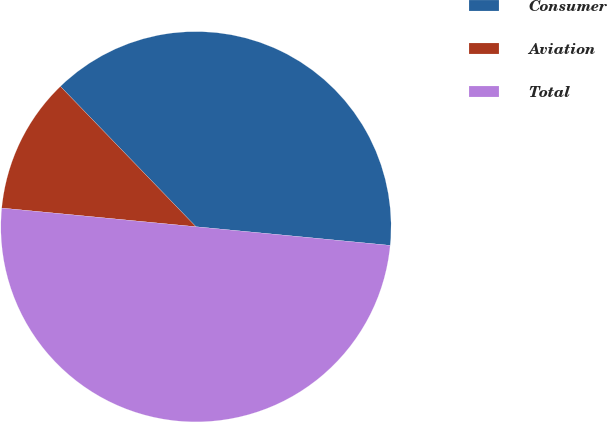Convert chart. <chart><loc_0><loc_0><loc_500><loc_500><pie_chart><fcel>Consumer<fcel>Aviation<fcel>Total<nl><fcel>38.75%<fcel>11.25%<fcel>50.0%<nl></chart> 